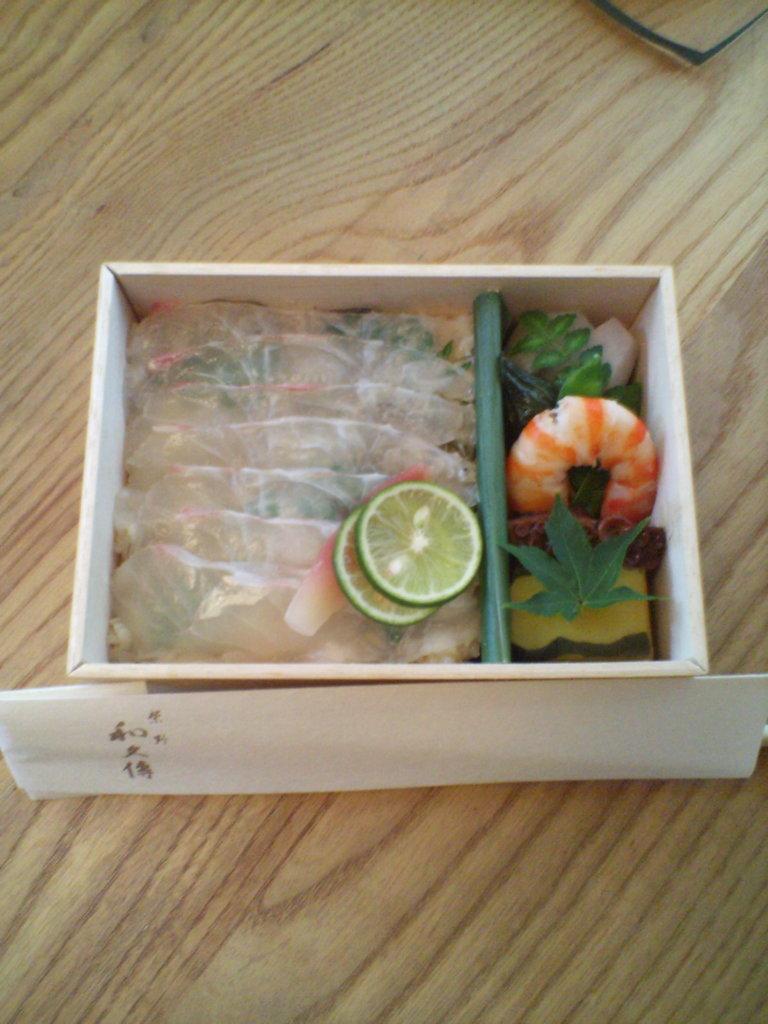Could you give a brief overview of what you see in this image? On this wooden surface we can see a card and box with food. 